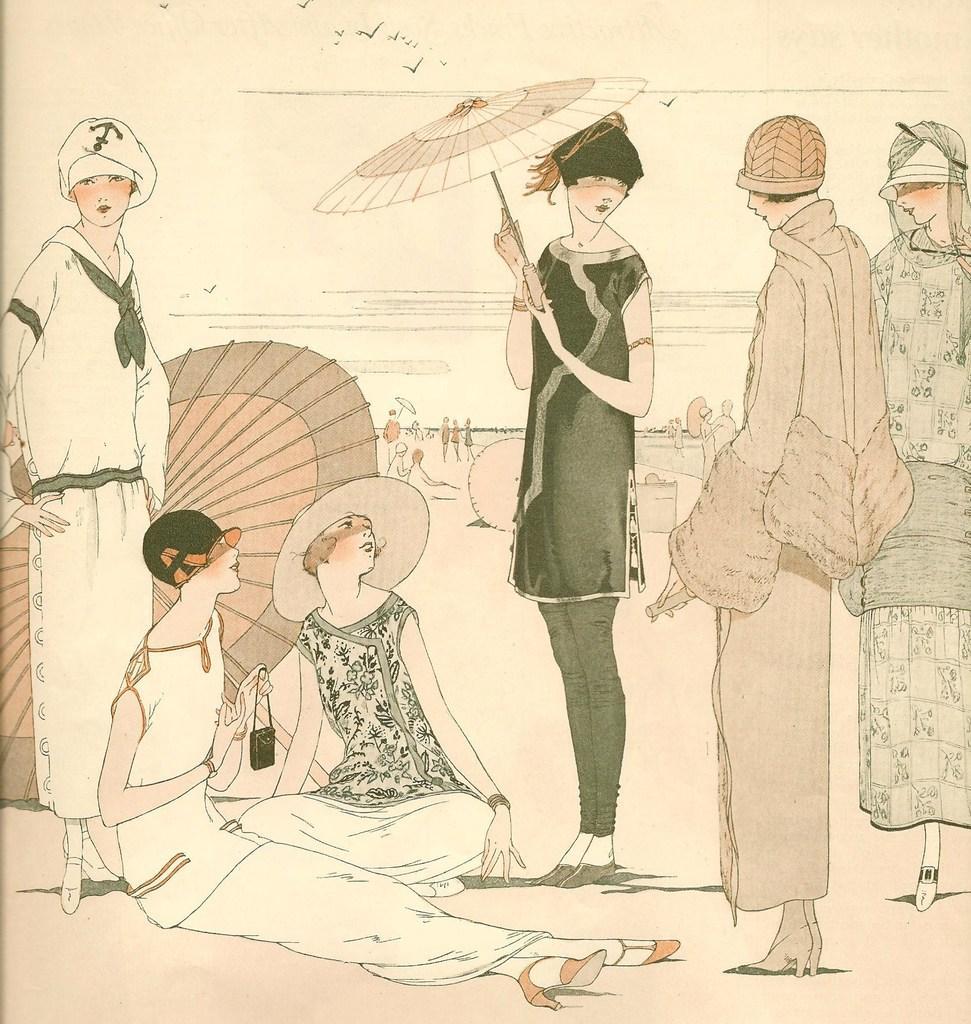Please provide a concise description of this image. This picture consists of drawing and we can see the group of people and we can see the two persons sitting on the ground and we can see the umbrellas. In the background we can see the sky, birds flying in the sky and we can see many other objects. 